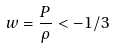<formula> <loc_0><loc_0><loc_500><loc_500>w = \frac { P } { \rho } < - 1 / 3</formula> 